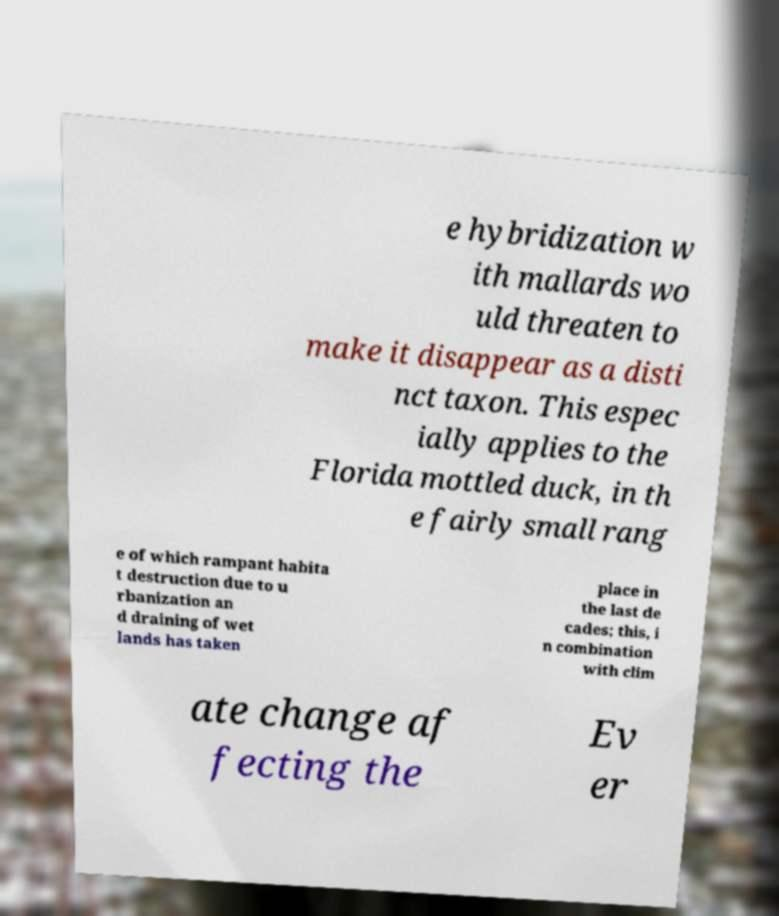For documentation purposes, I need the text within this image transcribed. Could you provide that? e hybridization w ith mallards wo uld threaten to make it disappear as a disti nct taxon. This espec ially applies to the Florida mottled duck, in th e fairly small rang e of which rampant habita t destruction due to u rbanization an d draining of wet lands has taken place in the last de cades; this, i n combination with clim ate change af fecting the Ev er 